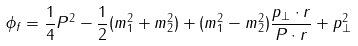Convert formula to latex. <formula><loc_0><loc_0><loc_500><loc_500>\phi _ { f } = \frac { 1 } { 4 } P ^ { 2 } - \frac { 1 } { 2 } ( m ^ { 2 } _ { 1 } + m _ { 2 } ^ { 2 } ) + ( m _ { 1 } ^ { 2 } - m _ { 2 } ^ { 2 } ) \frac { p _ { \bot } \cdot r } { P \cdot r } + p _ { \bot } ^ { 2 }</formula> 